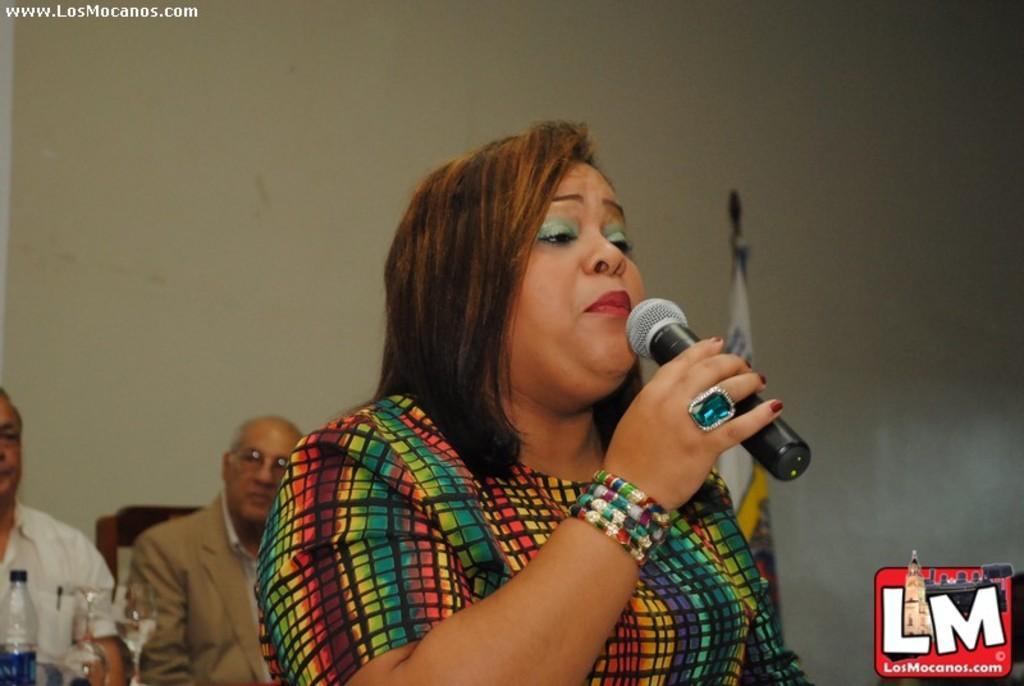Please provide a concise description of this image. There is a lady wearing bangles and ring is holding a mic. In the back two persons are sitting on the chair. In front of them there are glasses and bottle. In the back there's a wall and a flag. Also there is a watermark on the top left corner and bottom right corner. 